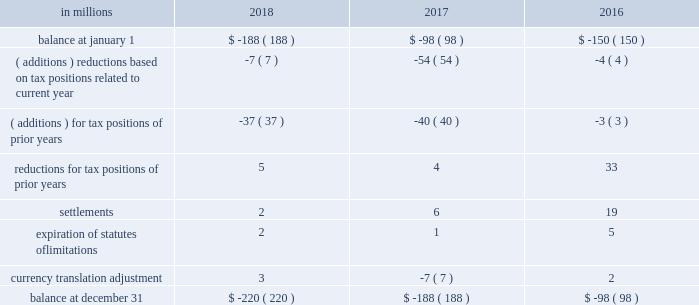( a ) the net change in the total valuation allowance for the years ended december 31 , 2018 and 2017 was an increase of $ 12 million and an increase of $ 26 million , respectively .
Deferred income tax assets and liabilities are recorded in the accompanying consolidated balance sheet under the captions deferred charges and other assets and deferred income taxes .
There was a decrease in deferred income tax assets principally relating to the utilization of u.s .
Federal alternative minimum tax credits as permitted under tax reform .
Deferred tax liabilities increased primarily due to the tax deferral of the book gain recognized on the transfer of the north american consumer packaging business to a subsidiary of graphic packaging holding company .
Of the $ 1.5 billion of deferred tax liabilities for forestlands , related installment sales , and investment in subsidiary , $ 884 million is attributable to an investment in subsidiary and relates to a 2006 international paper installment sale of forestlands and $ 538 million is attributable to a 2007 temple-inland installment sale of forestlands ( see note 14 ) .
A reconciliation of the beginning and ending amount of unrecognized tax benefits for the years ended december 31 , 2018 , 2017 and 2016 is as follows: .
If the company were to prevail on the unrecognized tax benefits recorded , substantially all of the balances at december 31 , 2018 , 2017 and 2016 would benefit the effective tax rate .
The company accrues interest on unrecognized tax benefits as a component of interest expense .
Penalties , if incurred , are recognized as a component of income tax expense .
The company had approximately $ 21 million and $ 17 million accrued for the payment of estimated interest and penalties associated with unrecognized tax benefits at december 31 , 2018 and 2017 , respectively .
The major jurisdictions where the company files income tax returns are the united states , brazil , france , poland and russia .
Generally , tax years 2006 through 2017 remain open and subject to examination by the relevant tax authorities .
The company frequently faces challenges regarding the amount of taxes due .
These challenges include positions taken by the company related to the timing , nature , and amount of deductions and the allocation of income among various tax jurisdictions .
Pending audit settlements and the expiration of statute of limitations could reduce the uncertain tax positions by $ 30 million during the next twelve months .
The brazilian federal revenue service has challenged the deductibility of goodwill amortization generated in a 2007 acquisition by international paper do brasil ltda. , a wholly-owned subsidiary of the company .
The company received assessments for the tax years 2007-2015 totaling approximately $ 150 million in tax , and $ 380 million in interest and penalties as of december 31 , 2018 ( adjusted for variation in currency exchange rates ) .
After a previous favorable ruling challenging the basis for these assessments , we received an unfavorable decision in october 2018 from the brazilian administrative council of tax appeals .
The company intends to further appeal the matter in the brazilian federal courts in 2019 ; however , this tax litigation matter may take many years to resolve .
The company believes that it has appropriately evaluated the transaction underlying these assessments , and has concluded based on brazilian tax law , that its tax position would be sustained .
The company intends to vigorously defend its position against the current assessments and any similar assessments that may be issued for tax years subsequent to 2015 .
International paper uses the flow-through method to account for investment tax credits earned on eligible open-loop biomass facilities and combined heat and power system expenditures .
Under this method , the investment tax credits are recognized as a reduction to income tax expense in the year they are earned rather than a reduction in the asset basis .
The company recorded a tax benefit of $ 6 million during 2018 and recorded a tax benefit of $ 68 million during 2017 related to investment tax credits earned in tax years 2013-2017. .
Unrecognized tax benefits change by what percent between 2016 and 2017? 
Computations: ((188 - 98) / 98)
Answer: 0.91837. 